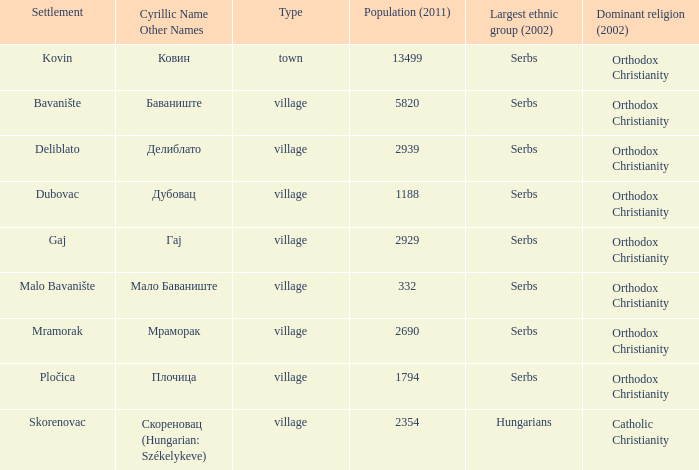What name does deliblato village have when written in cyrillic? Делиблато. 